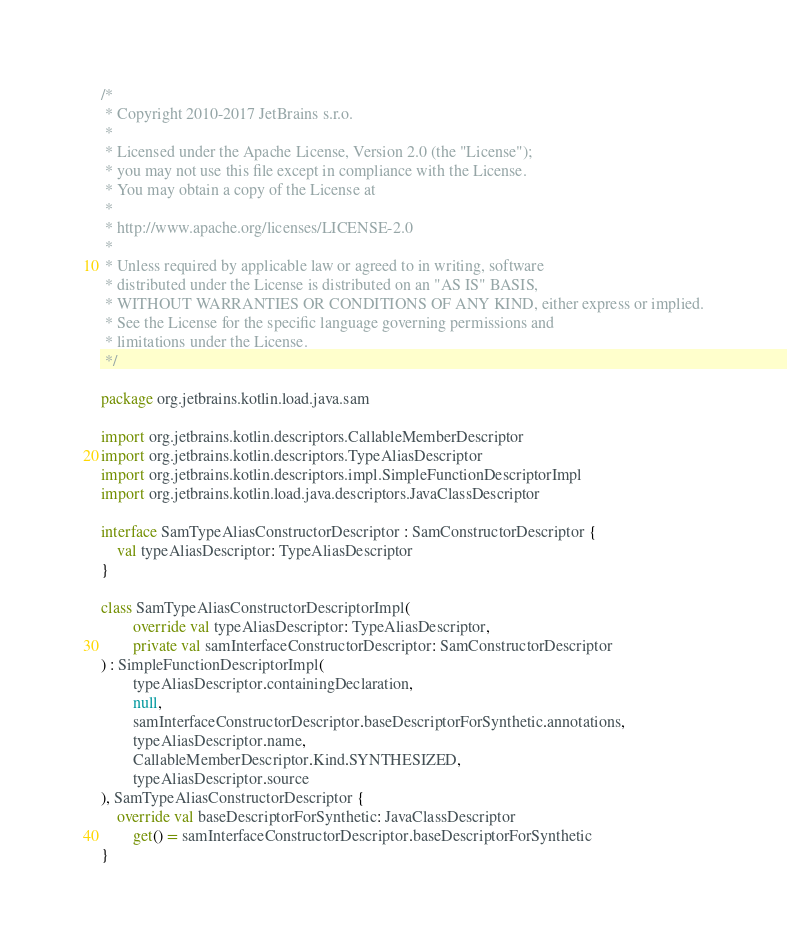<code> <loc_0><loc_0><loc_500><loc_500><_Kotlin_>/*
 * Copyright 2010-2017 JetBrains s.r.o.
 *
 * Licensed under the Apache License, Version 2.0 (the "License");
 * you may not use this file except in compliance with the License.
 * You may obtain a copy of the License at
 *
 * http://www.apache.org/licenses/LICENSE-2.0
 *
 * Unless required by applicable law or agreed to in writing, software
 * distributed under the License is distributed on an "AS IS" BASIS,
 * WITHOUT WARRANTIES OR CONDITIONS OF ANY KIND, either express or implied.
 * See the License for the specific language governing permissions and
 * limitations under the License.
 */

package org.jetbrains.kotlin.load.java.sam

import org.jetbrains.kotlin.descriptors.CallableMemberDescriptor
import org.jetbrains.kotlin.descriptors.TypeAliasDescriptor
import org.jetbrains.kotlin.descriptors.impl.SimpleFunctionDescriptorImpl
import org.jetbrains.kotlin.load.java.descriptors.JavaClassDescriptor

interface SamTypeAliasConstructorDescriptor : SamConstructorDescriptor {
    val typeAliasDescriptor: TypeAliasDescriptor
}

class SamTypeAliasConstructorDescriptorImpl(
        override val typeAliasDescriptor: TypeAliasDescriptor,
        private val samInterfaceConstructorDescriptor: SamConstructorDescriptor
) : SimpleFunctionDescriptorImpl(
        typeAliasDescriptor.containingDeclaration,
        null,
        samInterfaceConstructorDescriptor.baseDescriptorForSynthetic.annotations,
        typeAliasDescriptor.name,
        CallableMemberDescriptor.Kind.SYNTHESIZED,
        typeAliasDescriptor.source
), SamTypeAliasConstructorDescriptor {
    override val baseDescriptorForSynthetic: JavaClassDescriptor
        get() = samInterfaceConstructorDescriptor.baseDescriptorForSynthetic
}
</code> 